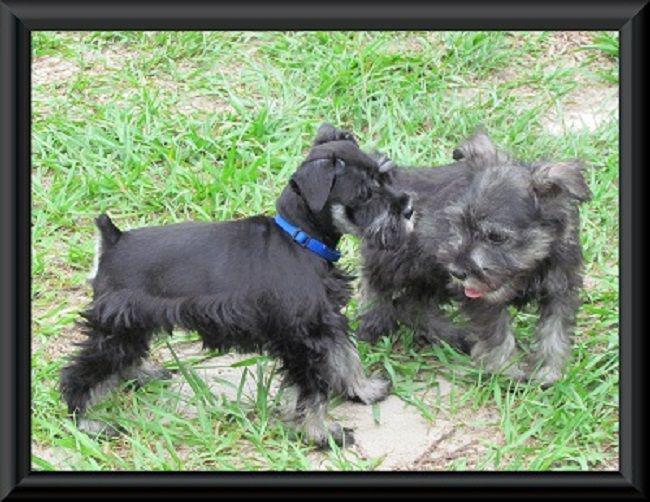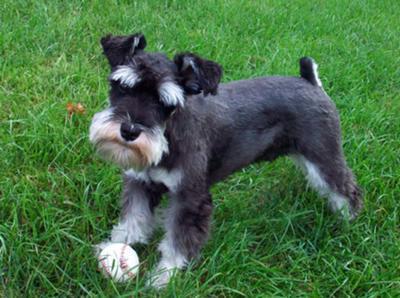The first image is the image on the left, the second image is the image on the right. Given the left and right images, does the statement "An image shows one schnauzer puppy standing in the grass near a toy." hold true? Answer yes or no. Yes. The first image is the image on the left, the second image is the image on the right. For the images shown, is this caption "A single dog stands in the grass in the image on the right." true? Answer yes or no. Yes. 